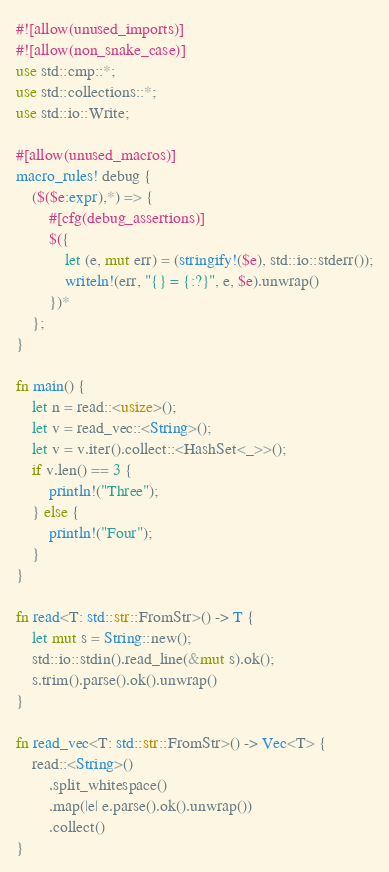<code> <loc_0><loc_0><loc_500><loc_500><_Rust_>#![allow(unused_imports)]
#![allow(non_snake_case)]
use std::cmp::*;
use std::collections::*;
use std::io::Write;

#[allow(unused_macros)]
macro_rules! debug {
    ($($e:expr),*) => {
        #[cfg(debug_assertions)]
        $({
            let (e, mut err) = (stringify!($e), std::io::stderr());
            writeln!(err, "{} = {:?}", e, $e).unwrap()
        })*
    };
}

fn main() {
    let n = read::<usize>();
    let v = read_vec::<String>();
    let v = v.iter().collect::<HashSet<_>>();
    if v.len() == 3 {
        println!("Three");
    } else {
        println!("Four");
    }
}

fn read<T: std::str::FromStr>() -> T {
    let mut s = String::new();
    std::io::stdin().read_line(&mut s).ok();
    s.trim().parse().ok().unwrap()
}

fn read_vec<T: std::str::FromStr>() -> Vec<T> {
    read::<String>()
        .split_whitespace()
        .map(|e| e.parse().ok().unwrap())
        .collect()
}
</code> 